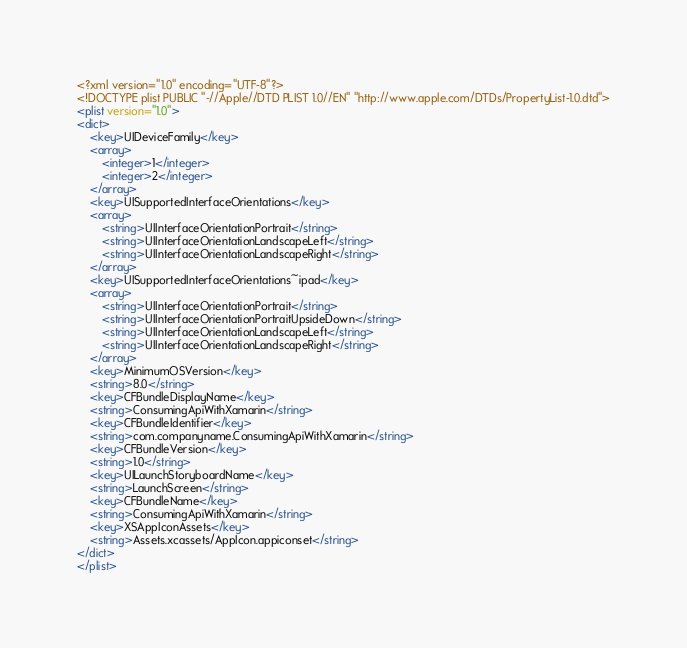Convert code to text. <code><loc_0><loc_0><loc_500><loc_500><_XML_><?xml version="1.0" encoding="UTF-8"?>
<!DOCTYPE plist PUBLIC "-//Apple//DTD PLIST 1.0//EN" "http://www.apple.com/DTDs/PropertyList-1.0.dtd">
<plist version="1.0">
<dict>
    <key>UIDeviceFamily</key>
    <array>
        <integer>1</integer>
        <integer>2</integer>
    </array>
    <key>UISupportedInterfaceOrientations</key>
    <array>
        <string>UIInterfaceOrientationPortrait</string>
        <string>UIInterfaceOrientationLandscapeLeft</string>
        <string>UIInterfaceOrientationLandscapeRight</string>
    </array>
    <key>UISupportedInterfaceOrientations~ipad</key>
    <array>
        <string>UIInterfaceOrientationPortrait</string>
        <string>UIInterfaceOrientationPortraitUpsideDown</string>
        <string>UIInterfaceOrientationLandscapeLeft</string>
        <string>UIInterfaceOrientationLandscapeRight</string>
    </array>
    <key>MinimumOSVersion</key>
    <string>8.0</string>
    <key>CFBundleDisplayName</key>
    <string>ConsumingApiWithXamarin</string>
    <key>CFBundleIdentifier</key>
    <string>com.companyname.ConsumingApiWithXamarin</string>
    <key>CFBundleVersion</key>
    <string>1.0</string>
    <key>UILaunchStoryboardName</key>
    <string>LaunchScreen</string>
    <key>CFBundleName</key>
    <string>ConsumingApiWithXamarin</string>
    <key>XSAppIconAssets</key>
    <string>Assets.xcassets/AppIcon.appiconset</string>
</dict>
</plist>
</code> 